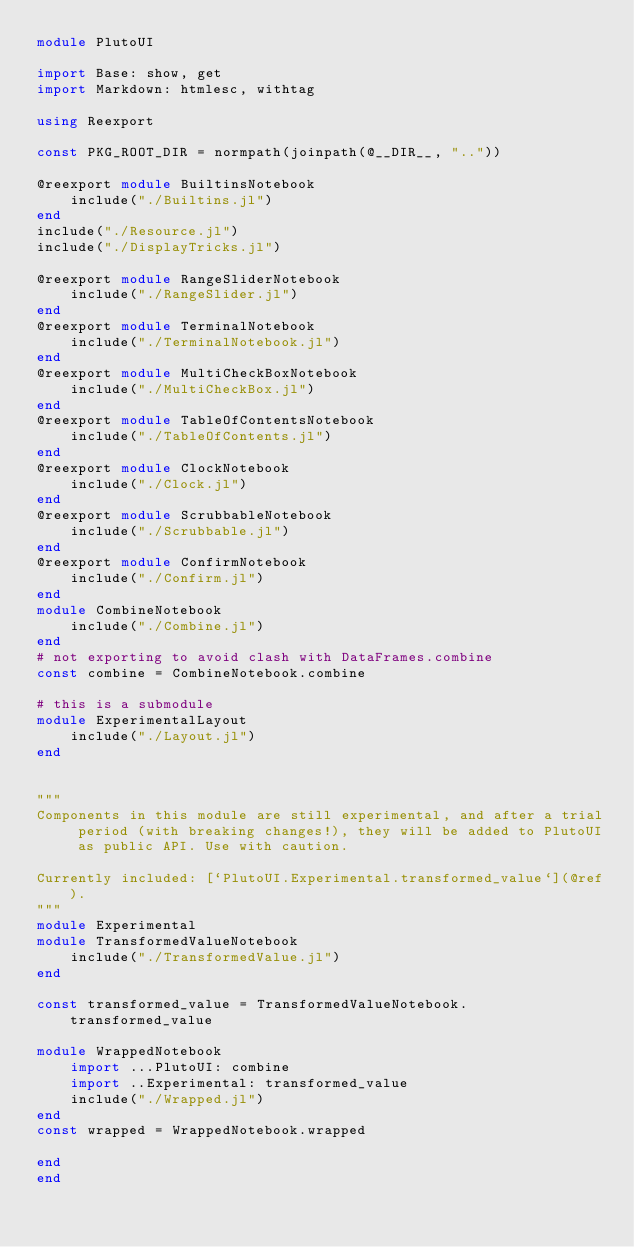<code> <loc_0><loc_0><loc_500><loc_500><_Julia_>module PlutoUI

import Base: show, get
import Markdown: htmlesc, withtag

using Reexport

const PKG_ROOT_DIR = normpath(joinpath(@__DIR__, ".."))

@reexport module BuiltinsNotebook
    include("./Builtins.jl")
end
include("./Resource.jl")
include("./DisplayTricks.jl")

@reexport module RangeSliderNotebook
    include("./RangeSlider.jl")
end
@reexport module TerminalNotebook
    include("./TerminalNotebook.jl")
end
@reexport module MultiCheckBoxNotebook
    include("./MultiCheckBox.jl")
end
@reexport module TableOfContentsNotebook
    include("./TableOfContents.jl")
end
@reexport module ClockNotebook
    include("./Clock.jl")
end
@reexport module ScrubbableNotebook
    include("./Scrubbable.jl")
end
@reexport module ConfirmNotebook
    include("./Confirm.jl")
end
module CombineNotebook
    include("./Combine.jl")
end
# not exporting to avoid clash with DataFrames.combine
const combine = CombineNotebook.combine

# this is a submodule
module ExperimentalLayout
    include("./Layout.jl")
end


"""
Components in this module are still experimental, and after a trial period (with breaking changes!), they will be added to PlutoUI as public API. Use with caution.

Currently included: [`PlutoUI.Experimental.transformed_value`](@ref).
"""
module Experimental
module TransformedValueNotebook
    include("./TransformedValue.jl")
end

const transformed_value = TransformedValueNotebook.transformed_value

module WrappedNotebook
    import ...PlutoUI: combine
    import ..Experimental: transformed_value
    include("./Wrapped.jl")
end
const wrapped = WrappedNotebook.wrapped

end
end
</code> 